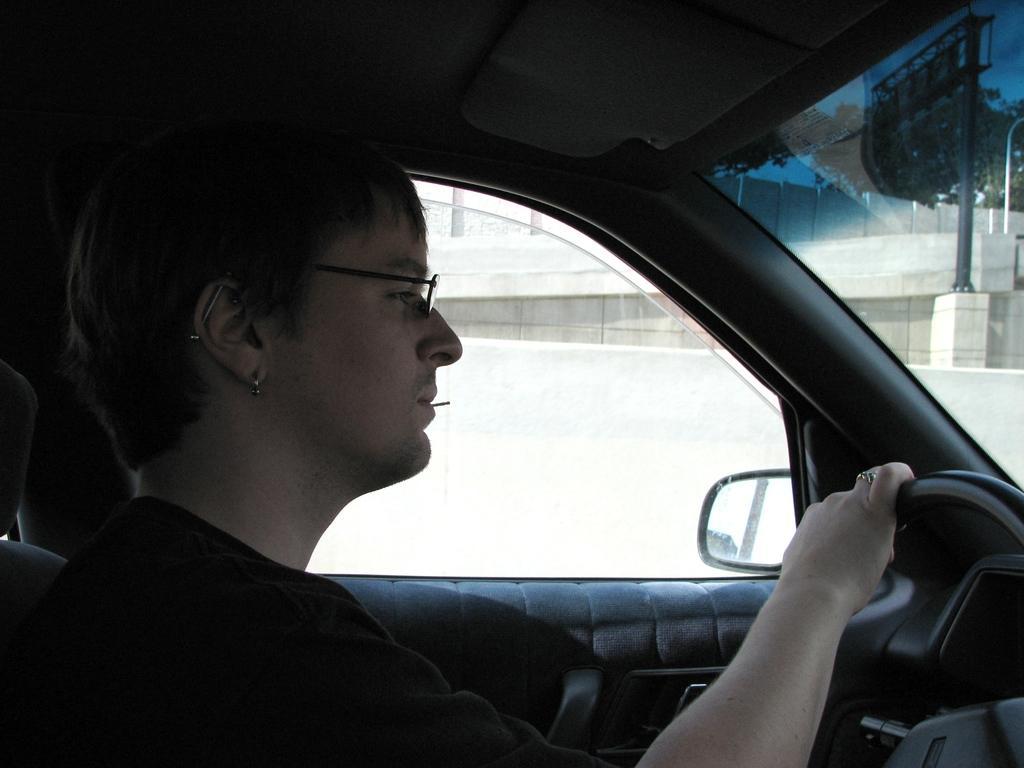How would you summarize this image in a sentence or two? This picture is clicked inside the vehicle which seems to be the car. In the foreground we can see a man sitting and seems to be driving the car. In the right corner we can see the windshield. In the background we can see the window and through the window we can see the sky, building, lamp posts, metal rods and the trees. 